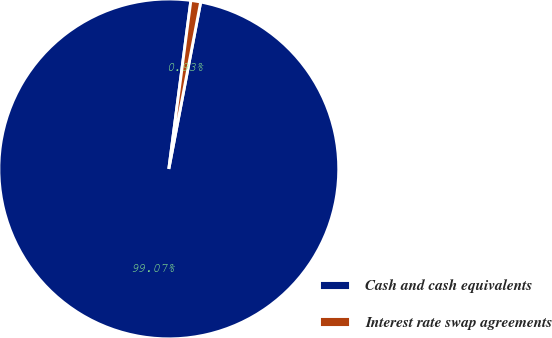<chart> <loc_0><loc_0><loc_500><loc_500><pie_chart><fcel>Cash and cash equivalents<fcel>Interest rate swap agreements<nl><fcel>99.07%<fcel>0.93%<nl></chart> 